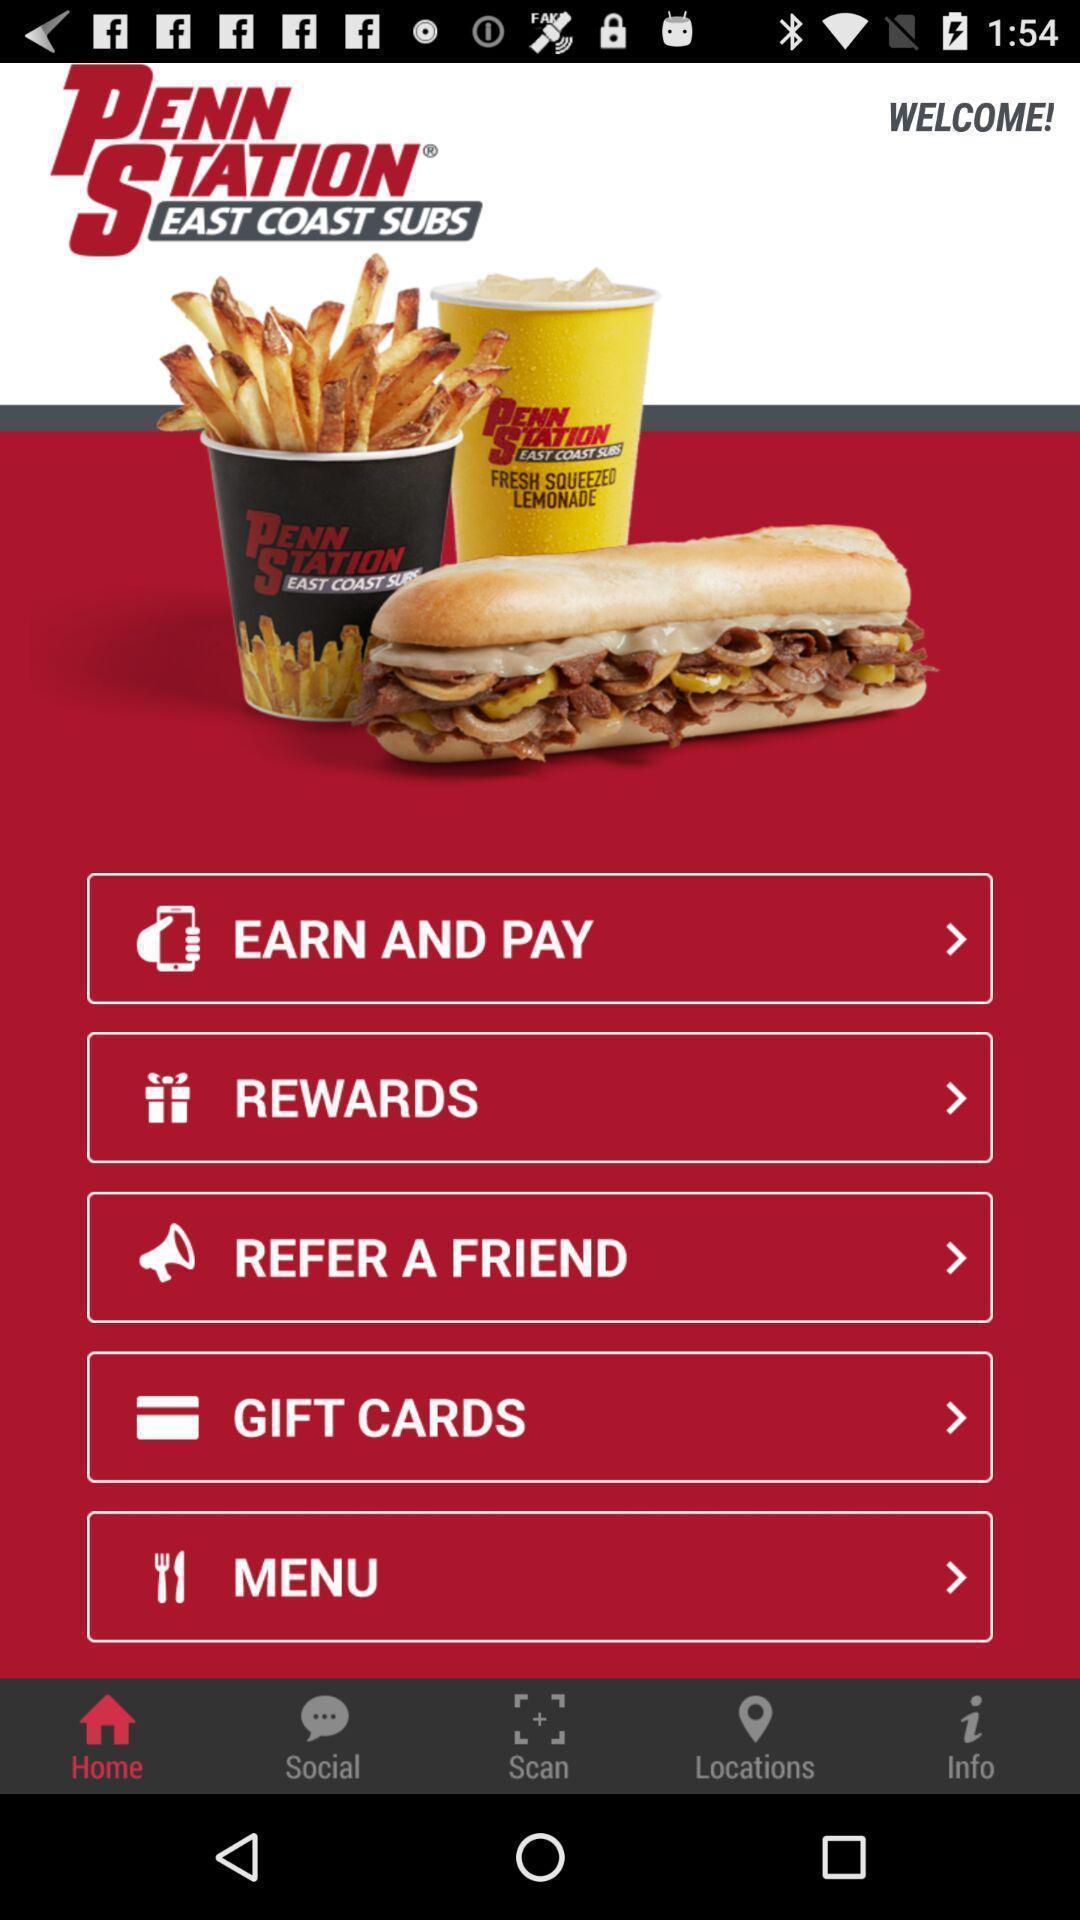Explain the elements present in this screenshot. Welcome page of application with different options. 